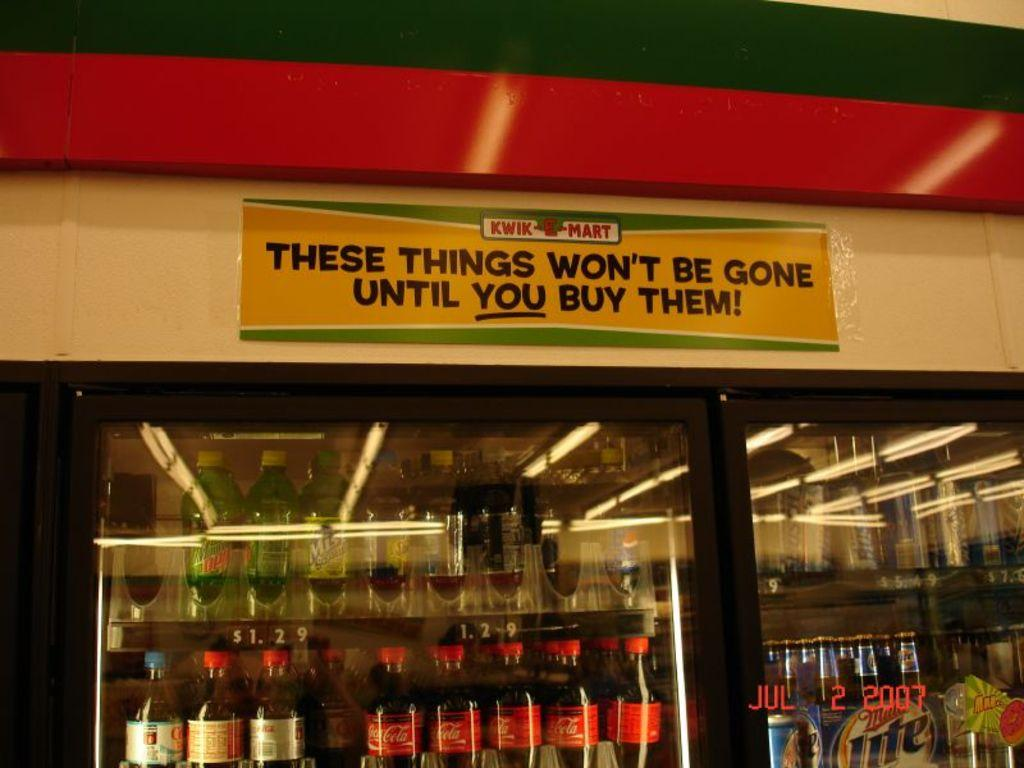<image>
Present a compact description of the photo's key features. Freezer in a store with soda inside and a sign on top for "Kwik Mart". 